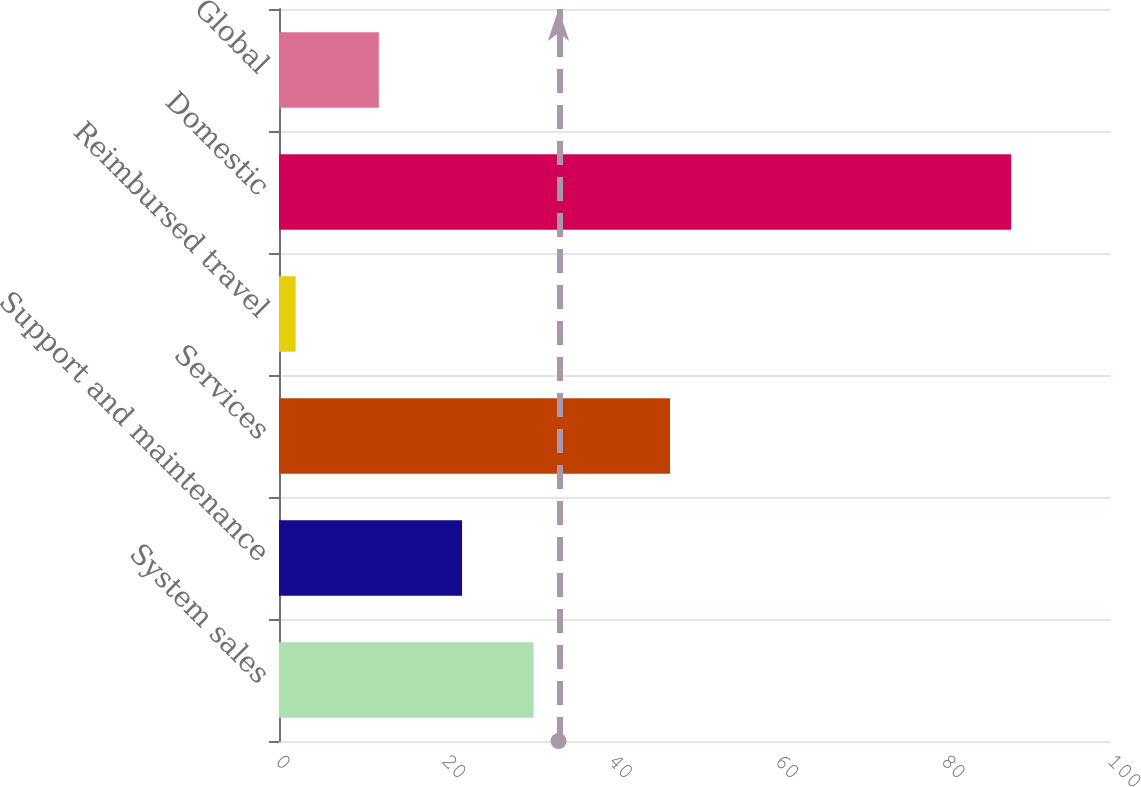<chart> <loc_0><loc_0><loc_500><loc_500><bar_chart><fcel>System sales<fcel>Support and maintenance<fcel>Services<fcel>Reimbursed travel<fcel>Domestic<fcel>Global<nl><fcel>30.6<fcel>22<fcel>47<fcel>2<fcel>88<fcel>12<nl></chart> 